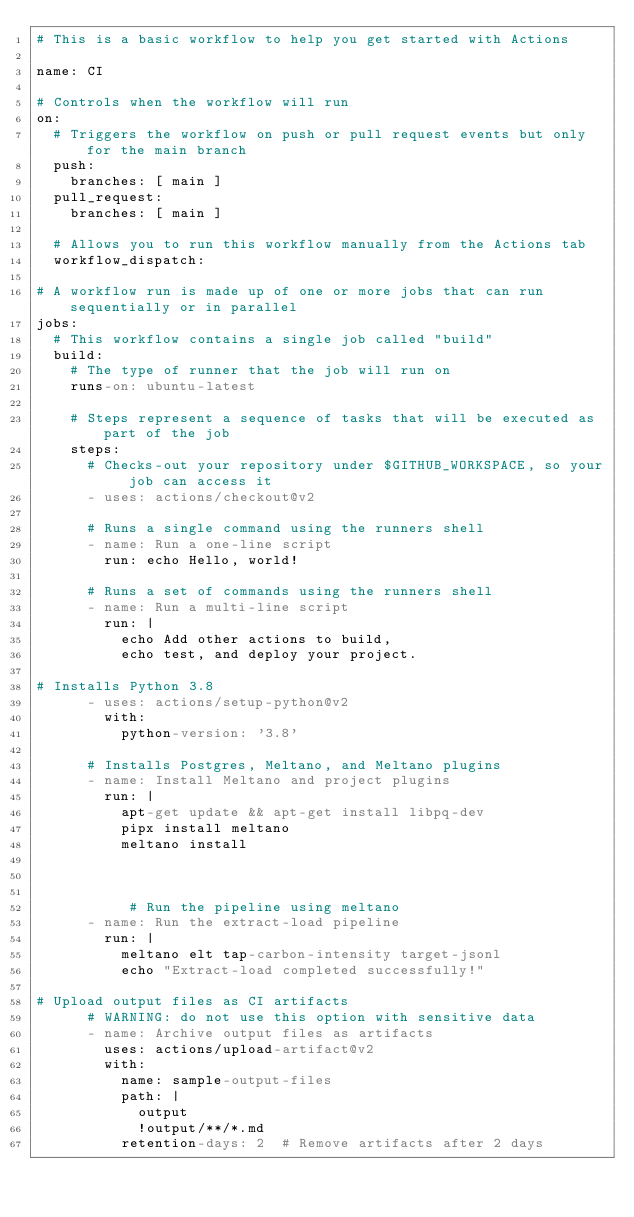<code> <loc_0><loc_0><loc_500><loc_500><_YAML_># This is a basic workflow to help you get started with Actions

name: CI

# Controls when the workflow will run
on:
  # Triggers the workflow on push or pull request events but only for the main branch
  push:
    branches: [ main ]
  pull_request:
    branches: [ main ]

  # Allows you to run this workflow manually from the Actions tab
  workflow_dispatch:

# A workflow run is made up of one or more jobs that can run sequentially or in parallel
jobs:
  # This workflow contains a single job called "build"
  build:
    # The type of runner that the job will run on
    runs-on: ubuntu-latest

    # Steps represent a sequence of tasks that will be executed as part of the job
    steps:
      # Checks-out your repository under $GITHUB_WORKSPACE, so your job can access it
      - uses: actions/checkout@v2

      # Runs a single command using the runners shell
      - name: Run a one-line script
        run: echo Hello, world!

      # Runs a set of commands using the runners shell
      - name: Run a multi-line script
        run: |
          echo Add other actions to build,
          echo test, and deploy your project.

# Installs Python 3.8
      - uses: actions/setup-python@v2
        with:
          python-version: '3.8'

      # Installs Postgres, Meltano, and Meltano plugins
      - name: Install Meltano and project plugins
        run: |
          apt-get update && apt-get install libpq-dev
          pipx install meltano
          meltano install
          
          
          
           # Run the pipeline using meltano
      - name: Run the extract-load pipeline
        run: |
          meltano elt tap-carbon-intensity target-jsonl
          echo "Extract-load completed successfully!"

# Upload output files as CI artifacts
      # WARNING: do not use this option with sensitive data
      - name: Archive output files as artifacts
        uses: actions/upload-artifact@v2
        with:
          name: sample-output-files
          path: |
            output
            !output/**/*.md
          retention-days: 2  # Remove artifacts after 2 days
</code> 